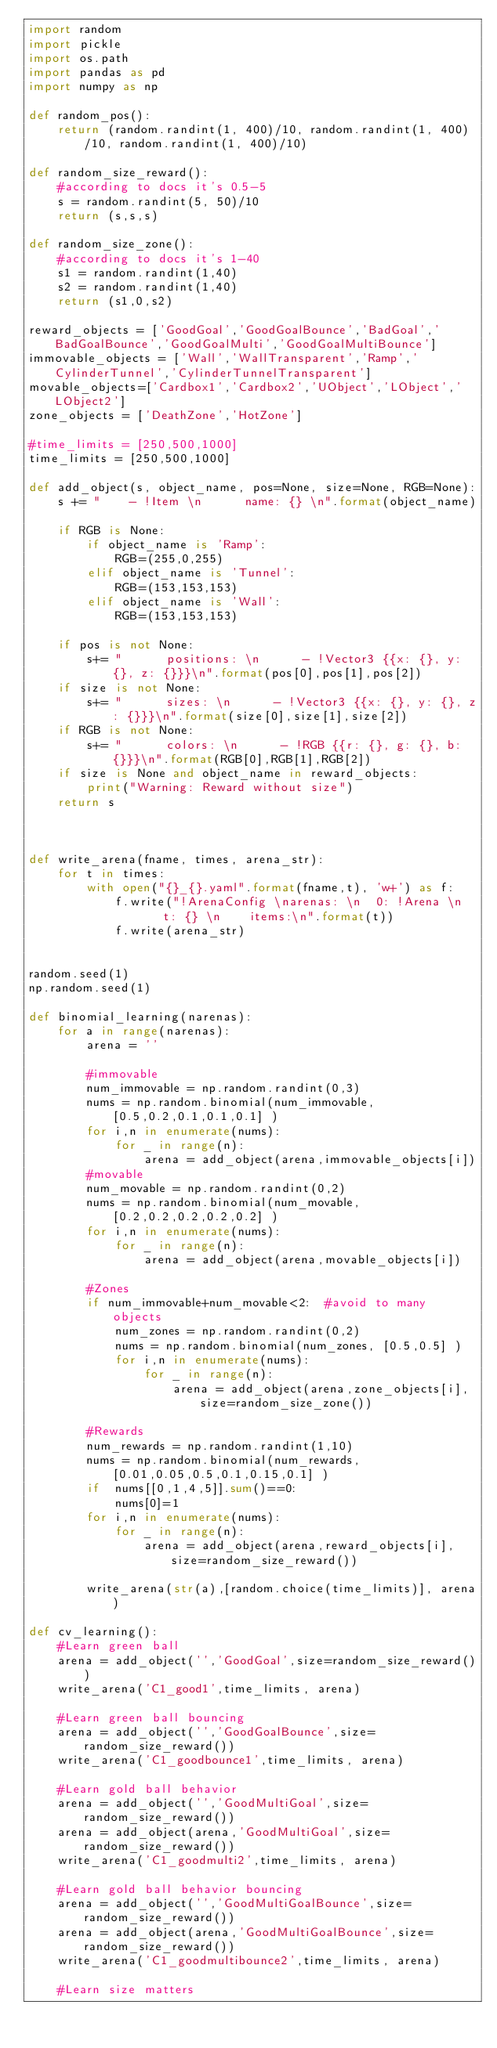<code> <loc_0><loc_0><loc_500><loc_500><_Python_>import random
import pickle
import os.path
import pandas as pd
import numpy as np

def random_pos():
    return (random.randint(1, 400)/10, random.randint(1, 400)/10, random.randint(1, 400)/10)

def random_size_reward():
    #according to docs it's 0.5-5
    s = random.randint(5, 50)/10
    return (s,s,s)

def random_size_zone():
    #according to docs it's 1-40
    s1 = random.randint(1,40)
    s2 = random.randint(1,40)
    return (s1,0,s2)

reward_objects = ['GoodGoal','GoodGoalBounce','BadGoal','BadGoalBounce','GoodGoalMulti','GoodGoalMultiBounce']
immovable_objects = ['Wall','WallTransparent','Ramp','CylinderTunnel','CylinderTunnelTransparent']
movable_objects=['Cardbox1','Cardbox2','UObject','LObject','LObject2']
zone_objects = ['DeathZone','HotZone']

#time_limits = [250,500,1000]
time_limits = [250,500,1000]

def add_object(s, object_name, pos=None, size=None, RGB=None):
    s += "    - !Item \n      name: {} \n".format(object_name)

    if RGB is None:
        if object_name is 'Ramp':
            RGB=(255,0,255)
        elif object_name is 'Tunnel':
            RGB=(153,153,153) 
        elif object_name is 'Wall':
            RGB=(153,153,153) 

    if pos is not None:
        s+= "      positions: \n      - !Vector3 {{x: {}, y: {}, z: {}}}\n".format(pos[0],pos[1],pos[2])
    if size is not None:
        s+= "      sizes: \n      - !Vector3 {{x: {}, y: {}, z: {}}}\n".format(size[0],size[1],size[2])
    if RGB is not None:
        s+= "      colors: \n      - !RGB {{r: {}, g: {}, b: {}}}\n".format(RGB[0],RGB[1],RGB[2])
    if size is None and object_name in reward_objects:
        print("Warning: Reward without size")
    return s



def write_arena(fname, times, arena_str):
    for t in times:
        with open("{}_{}.yaml".format(fname,t), 'w+') as f:
            f.write("!ArenaConfig \narenas: \n  0: !Arena \n    t: {} \n    items:\n".format(t))
            f.write(arena_str)


random.seed(1)
np.random.seed(1)

def binomial_learning(narenas):
    for a in range(narenas):
        arena = ''    

        #immovable
        num_immovable = np.random.randint(0,3)
        nums = np.random.binomial(num_immovable, [0.5,0.2,0.1,0.1,0.1] )
        for i,n in enumerate(nums):
            for _ in range(n):
                arena = add_object(arena,immovable_objects[i])
        #movable
        num_movable = np.random.randint(0,2)
        nums = np.random.binomial(num_movable, [0.2,0.2,0.2,0.2,0.2] )
        for i,n in enumerate(nums):
            for _ in range(n):
                arena = add_object(arena,movable_objects[i])

        #Zones
        if num_immovable+num_movable<2:  #avoid to many objects
            num_zones = np.random.randint(0,2)
            nums = np.random.binomial(num_zones, [0.5,0.5] )
            for i,n in enumerate(nums):
                for _ in range(n):
                    arena = add_object(arena,zone_objects[i],size=random_size_zone())

        #Rewards
        num_rewards = np.random.randint(1,10)
        nums = np.random.binomial(num_rewards, [0.01,0.05,0.5,0.1,0.15,0.1] )
        if  nums[[0,1,4,5]].sum()==0: 
            nums[0]=1
        for i,n in enumerate(nums):
            for _ in range(n):
                arena = add_object(arena,reward_objects[i],size=random_size_reward())    
            
        write_arena(str(a),[random.choice(time_limits)], arena)

def cv_learning():
    #Learn green ball
    arena = add_object('','GoodGoal',size=random_size_reward())
    write_arena('C1_good1',time_limits, arena)

    #Learn green ball bouncing
    arena = add_object('','GoodGoalBounce',size=random_size_reward())
    write_arena('C1_goodbounce1',time_limits, arena)

    #Learn gold ball behavior
    arena = add_object('','GoodMultiGoal',size=random_size_reward())
    arena = add_object(arena,'GoodMultiGoal',size=random_size_reward())
    write_arena('C1_goodmulti2',time_limits, arena)

    #Learn gold ball behavior bouncing
    arena = add_object('','GoodMultiGoalBounce',size=random_size_reward())
    arena = add_object(arena,'GoodMultiGoalBounce',size=random_size_reward())
    write_arena('C1_goodmultibounce2',time_limits, arena)

    #Learn size matters</code> 